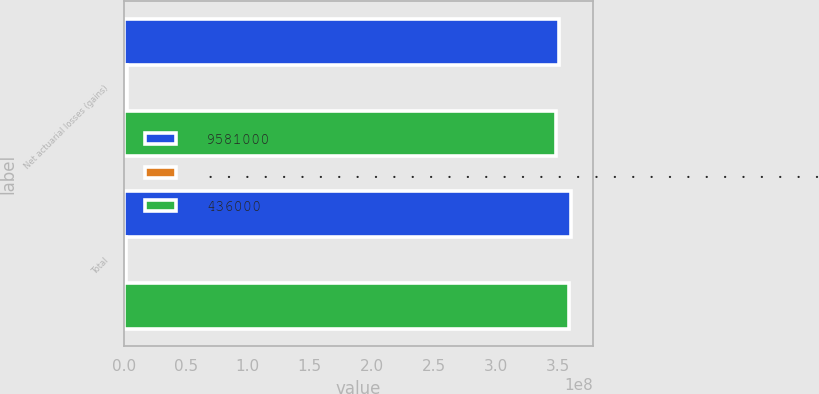Convert chart. <chart><loc_0><loc_0><loc_500><loc_500><stacked_bar_chart><ecel><fcel>Net actuarial losses (gains)<fcel>Total<nl><fcel>9581000<fcel>3.51344e+08<fcel>3.60489e+08<nl><fcel>. . . . . . . . . . . . . . . . . . . . . . . . . . . . . . . . . . . . . . . . .  9145000<fcel>2.912e+06<fcel>1.722e+06<nl><fcel>436000<fcel>3.48432e+08<fcel>3.58767e+08<nl></chart> 